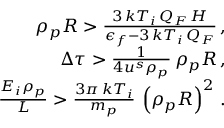<formula> <loc_0><loc_0><loc_500><loc_500>\begin{array} { r l r } & { \rho _ { p } R > \frac { 3 \, k T _ { i } \, Q _ { F } \, H } { \epsilon _ { f } - 3 \, k T _ { i } \, Q _ { F } } \, , } \\ & { \Delta \tau > \frac { 1 } { 4 u ^ { s } \rho _ { p } } \, \rho _ { p } R \, , } \\ & { \frac { E _ { i } \rho _ { p } } { L } > \frac { 3 \pi \, k T _ { i } } { m _ { p } } \, \left ( \rho _ { p } R \right ) ^ { 2 } \, . } \end{array}</formula> 